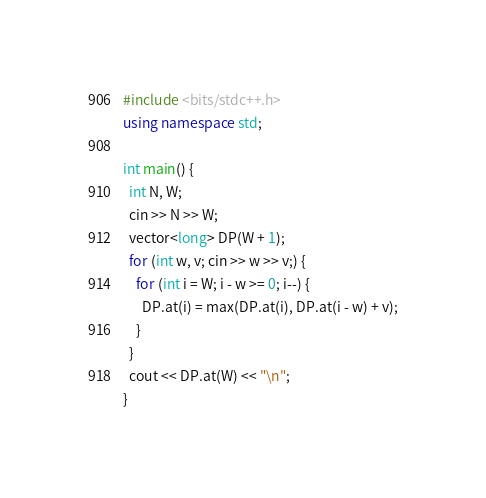Convert code to text. <code><loc_0><loc_0><loc_500><loc_500><_C++_>#include <bits/stdc++.h>
using namespace std;

int main() {
  int N, W;
  cin >> N >> W;
  vector<long> DP(W + 1);
  for (int w, v; cin >> w >> v;) {
    for (int i = W; i - w >= 0; i--) {
      DP.at(i) = max(DP.at(i), DP.at(i - w) + v);
    }
  }
  cout << DP.at(W) << "\n";
}</code> 